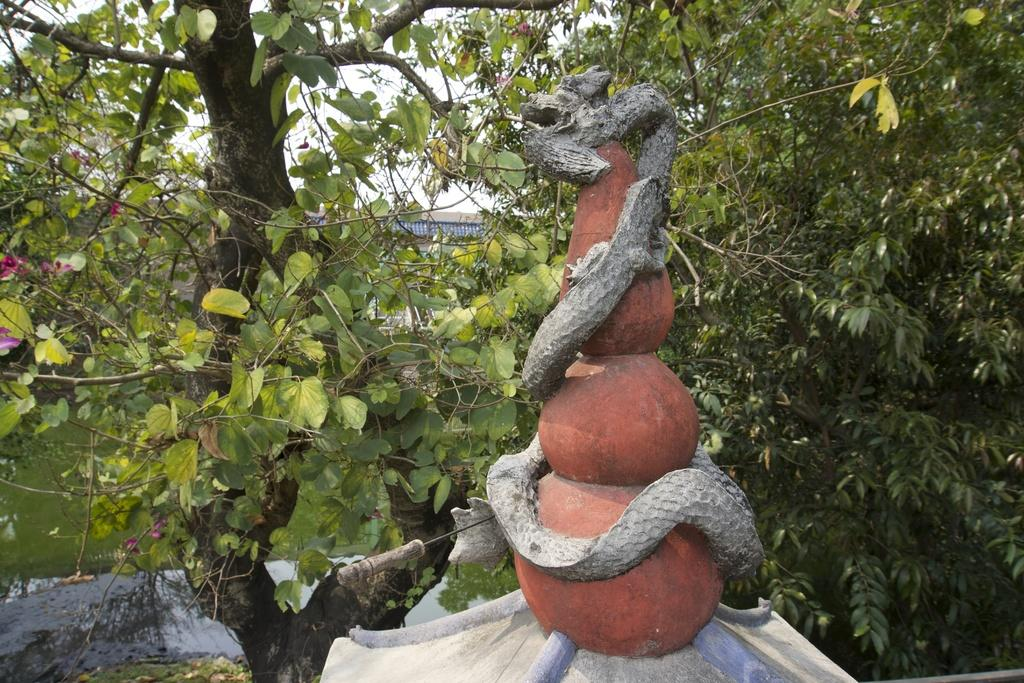What type of vegetation is present in the image? There are trees with branches and leaves in the image. What kind of artwork can be seen in the image? The image appears to contain a sculpture. What is the color of the water visible at the bottom of the image? The water visible at the bottom of the image is green-colored. Is there any smoke coming from the trees in the image? No, there is no smoke present in the image. Can you tell me what type of animals are in the zoo depicted in the image? There is no zoo present in the image; it features trees, a sculpture, and green-colored water. 